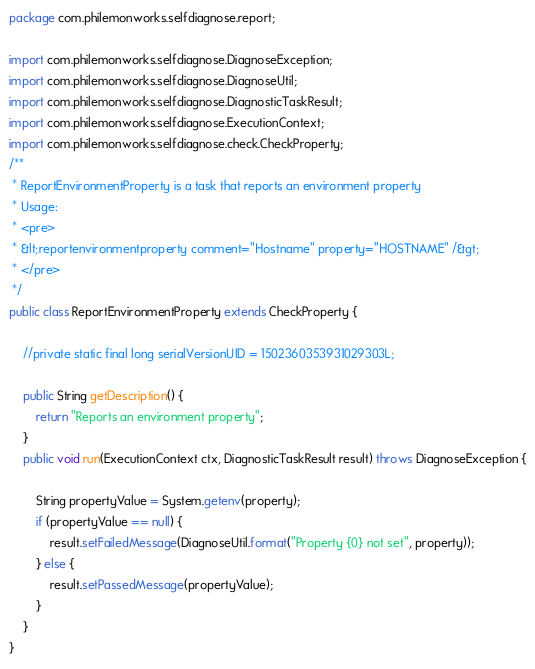Convert code to text. <code><loc_0><loc_0><loc_500><loc_500><_Java_>package com.philemonworks.selfdiagnose.report;

import com.philemonworks.selfdiagnose.DiagnoseException;
import com.philemonworks.selfdiagnose.DiagnoseUtil;
import com.philemonworks.selfdiagnose.DiagnosticTaskResult;
import com.philemonworks.selfdiagnose.ExecutionContext;
import com.philemonworks.selfdiagnose.check.CheckProperty;
/**
 * ReportEnvironmentProperty is a task that reports an environment property
 * Usage:
 * <pre>
 * &lt;reportenvironmentproperty comment="Hostname" property="HOSTNAME" /&gt;
 * </pre>
 */
public class ReportEnvironmentProperty extends CheckProperty {

    //private static final long serialVersionUID = 1502360353931029303L;

    public String getDescription() {
        return "Reports an environment property";
    }
    public void run(ExecutionContext ctx, DiagnosticTaskResult result) throws DiagnoseException {

        String propertyValue = System.getenv(property);
        if (propertyValue == null) {
            result.setFailedMessage(DiagnoseUtil.format("Property {0} not set", property));
        } else {
            result.setPassedMessage(propertyValue);
        }
    }
}
</code> 